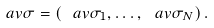<formula> <loc_0><loc_0><loc_500><loc_500>\ a v { \sigma } = \left ( \ a v { \sigma _ { 1 } } , \dots , \ a v { \sigma _ { N } } \right ) .</formula> 